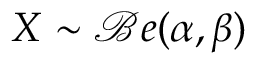<formula> <loc_0><loc_0><loc_500><loc_500>X \sim { \mathcal { B } } e ( \alpha , \beta )</formula> 